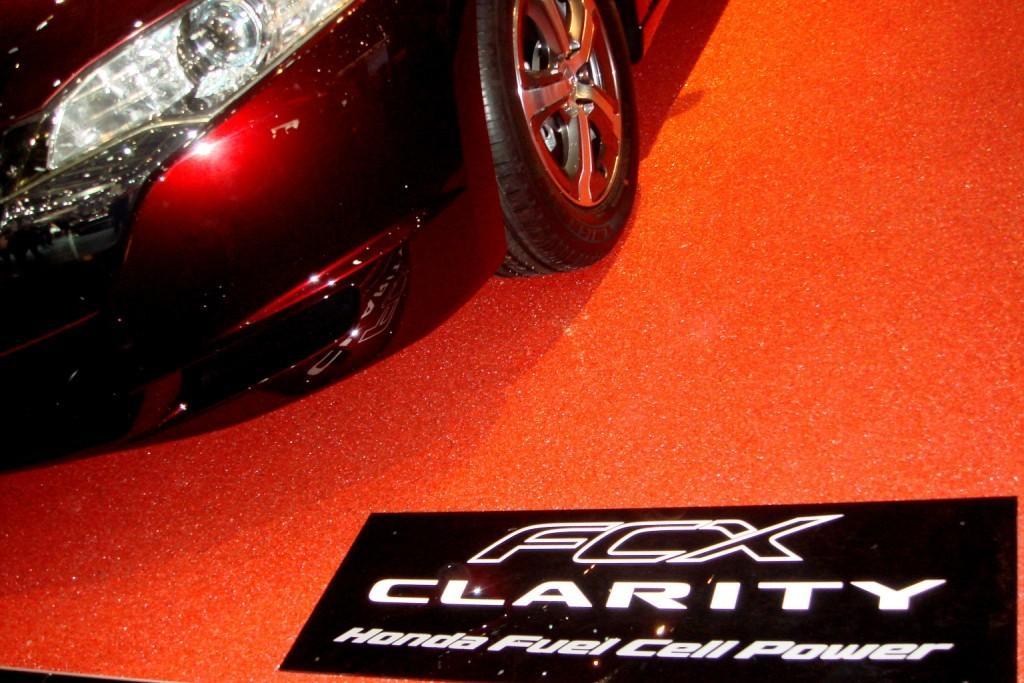Could you give a brief overview of what you see in this image? In this image, this looks like a car, which is maroon in color. I can see a wheel and a headlight attached to the car. I think this is a board, which is placed on the red carpet. 